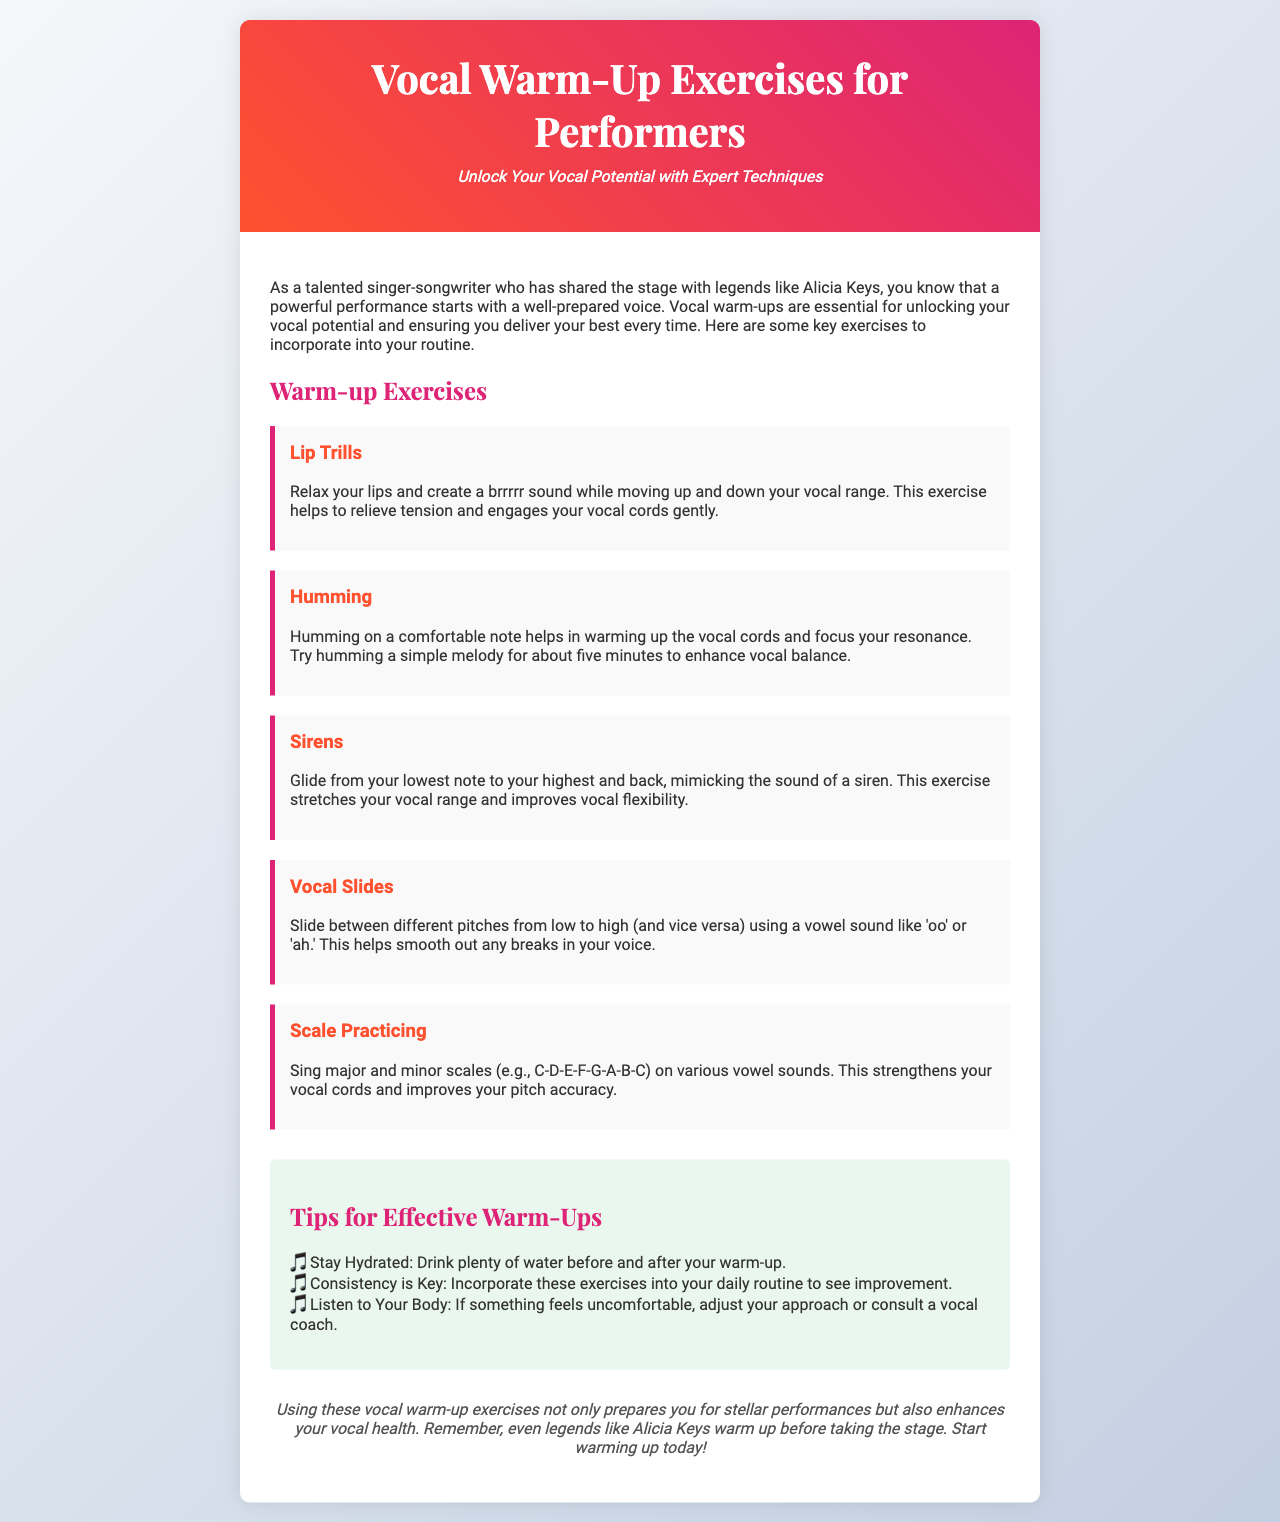What is the title of the brochure? The title of the brochure is prominently displayed at the top of the document.
Answer: Vocal Warm-Up Exercises for Performers What is the subtitle of the brochure? The subtitle provides additional context and is found just below the title.
Answer: Unlock Your Vocal Potential with Expert Techniques What is one exercise mentioned for warming up the voice? Exercises are listed under the "Warm-up Exercises" section, providing several options.
Answer: Lip Trills How long should you try humming a melody for effective warming up? The duration of the humming exercise is specified clearly in the text.
Answer: about five minutes What is the main benefit of warm-up exercises mentioned in the brochure? The benefit relates to performance and voice health, discussed in the conclusion.
Answer: enhances vocal health What color is the header background of the brochure? Descriptions of the design elements, including colors, are included in the styling sections.
Answer: linear-gradient from #FF512F to #DD2476 Name one tip for effective warm-ups. The tips are outlined in a designated section, listing advice for performers.
Answer: Stay Hydrated Which famous artist is mentioned in connection with warming up before performances? The document references a well-known singer to emphasize the importance of warm-ups.
Answer: Alicia Keys How many warm-up exercises are listed in the document? The number of exercises can be counted from the section labeled "Warm-up Exercises."
Answer: Five 